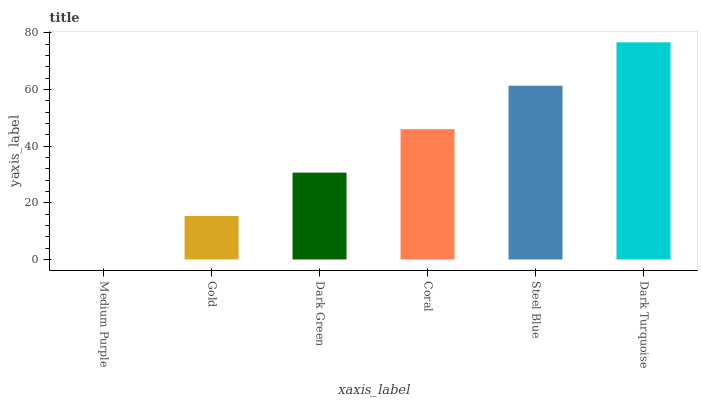Is Medium Purple the minimum?
Answer yes or no. Yes. Is Dark Turquoise the maximum?
Answer yes or no. Yes. Is Gold the minimum?
Answer yes or no. No. Is Gold the maximum?
Answer yes or no. No. Is Gold greater than Medium Purple?
Answer yes or no. Yes. Is Medium Purple less than Gold?
Answer yes or no. Yes. Is Medium Purple greater than Gold?
Answer yes or no. No. Is Gold less than Medium Purple?
Answer yes or no. No. Is Coral the high median?
Answer yes or no. Yes. Is Dark Green the low median?
Answer yes or no. Yes. Is Gold the high median?
Answer yes or no. No. Is Medium Purple the low median?
Answer yes or no. No. 